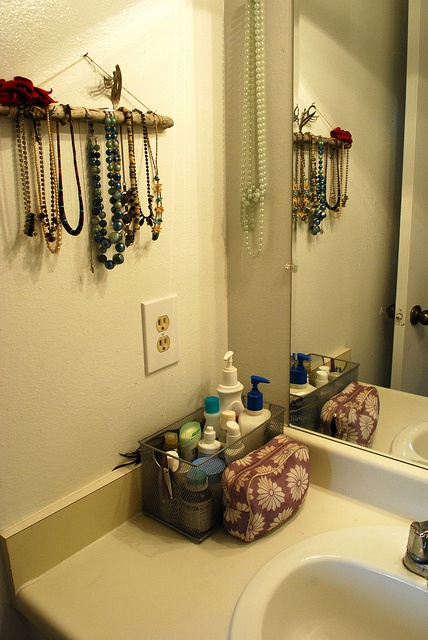Describe the objects in this image and their specific colors. I can see sink in khaki, tan, and olive tones, handbag in khaki, maroon, black, and brown tones, bottle in khaki, black, and darkgreen tones, bottle in khaki, black, olive, and tan tones, and bottle in khaki, tan, and olive tones in this image. 